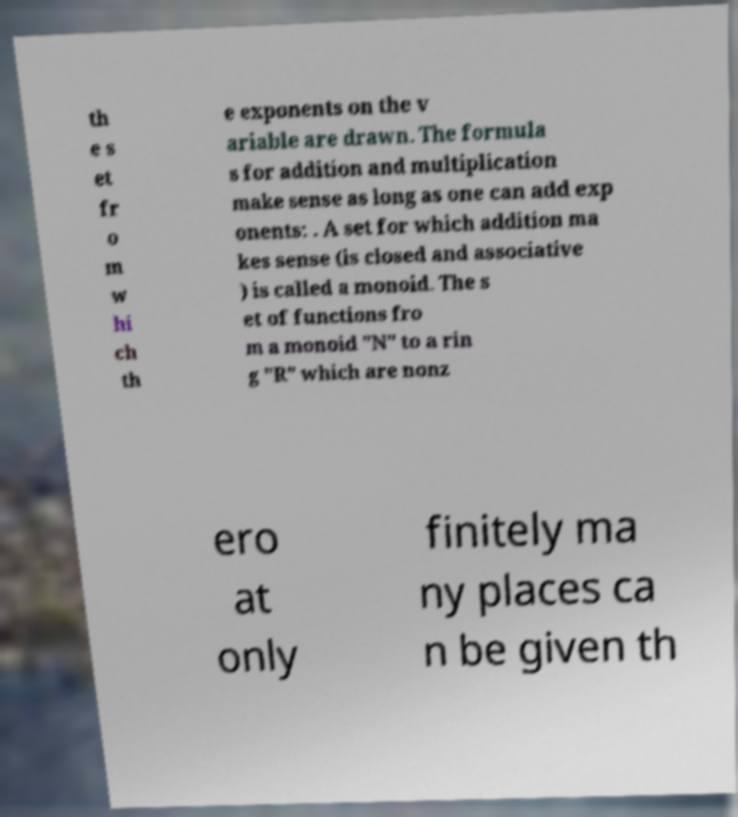I need the written content from this picture converted into text. Can you do that? th e s et fr o m w hi ch th e exponents on the v ariable are drawn. The formula s for addition and multiplication make sense as long as one can add exp onents: . A set for which addition ma kes sense (is closed and associative ) is called a monoid. The s et of functions fro m a monoid "N" to a rin g "R" which are nonz ero at only finitely ma ny places ca n be given th 